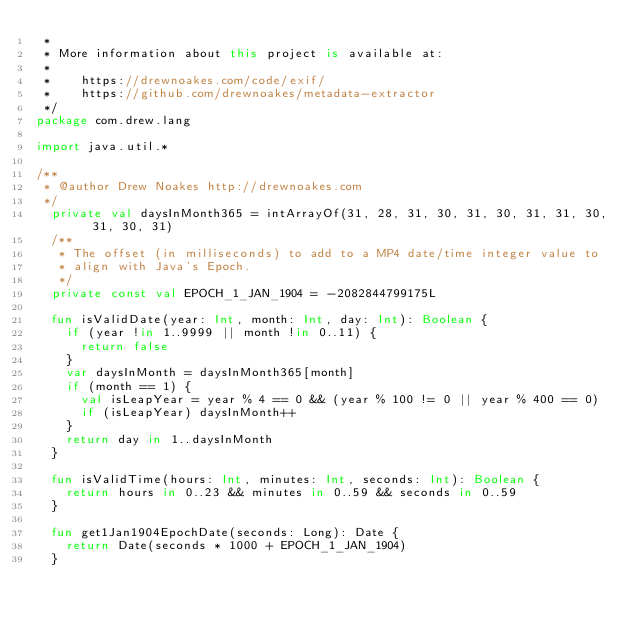<code> <loc_0><loc_0><loc_500><loc_500><_Kotlin_> *
 * More information about this project is available at:
 *
 *    https://drewnoakes.com/code/exif/
 *    https://github.com/drewnoakes/metadata-extractor
 */
package com.drew.lang

import java.util.*

/**
 * @author Drew Noakes http://drewnoakes.com
 */
  private val daysInMonth365 = intArrayOf(31, 28, 31, 30, 31, 30, 31, 31, 30, 31, 30, 31)
  /**
   * The offset (in milliseconds) to add to a MP4 date/time integer value to
   * align with Java's Epoch.
   */
  private const val EPOCH_1_JAN_1904 = -2082844799175L

  fun isValidDate(year: Int, month: Int, day: Int): Boolean {
    if (year !in 1..9999 || month !in 0..11) {
      return false
    }
    var daysInMonth = daysInMonth365[month]
    if (month == 1) {
      val isLeapYear = year % 4 == 0 && (year % 100 != 0 || year % 400 == 0)
      if (isLeapYear) daysInMonth++
    }
    return day in 1..daysInMonth
  }

  fun isValidTime(hours: Int, minutes: Int, seconds: Int): Boolean {
    return hours in 0..23 && minutes in 0..59 && seconds in 0..59
  }

  fun get1Jan1904EpochDate(seconds: Long): Date {
    return Date(seconds * 1000 + EPOCH_1_JAN_1904)
  }
</code> 